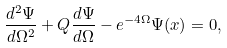<formula> <loc_0><loc_0><loc_500><loc_500>\frac { d ^ { 2 } \Psi } { d \Omega ^ { 2 } } + Q \frac { d \Psi } { d \Omega } - e ^ { - 4 \Omega } \Psi ( x ) = 0 ,</formula> 